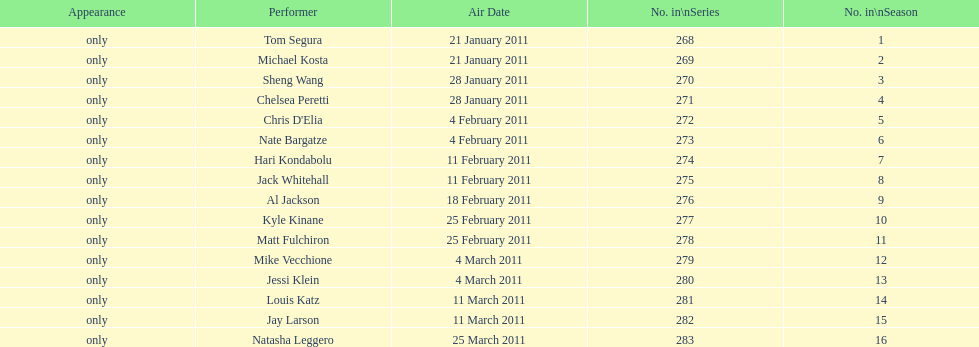Which month had the most performers? February. 